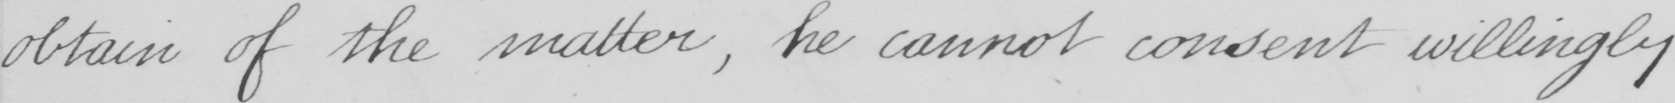Please transcribe the handwritten text in this image. obtain of the matter , he cannot consent willingly 